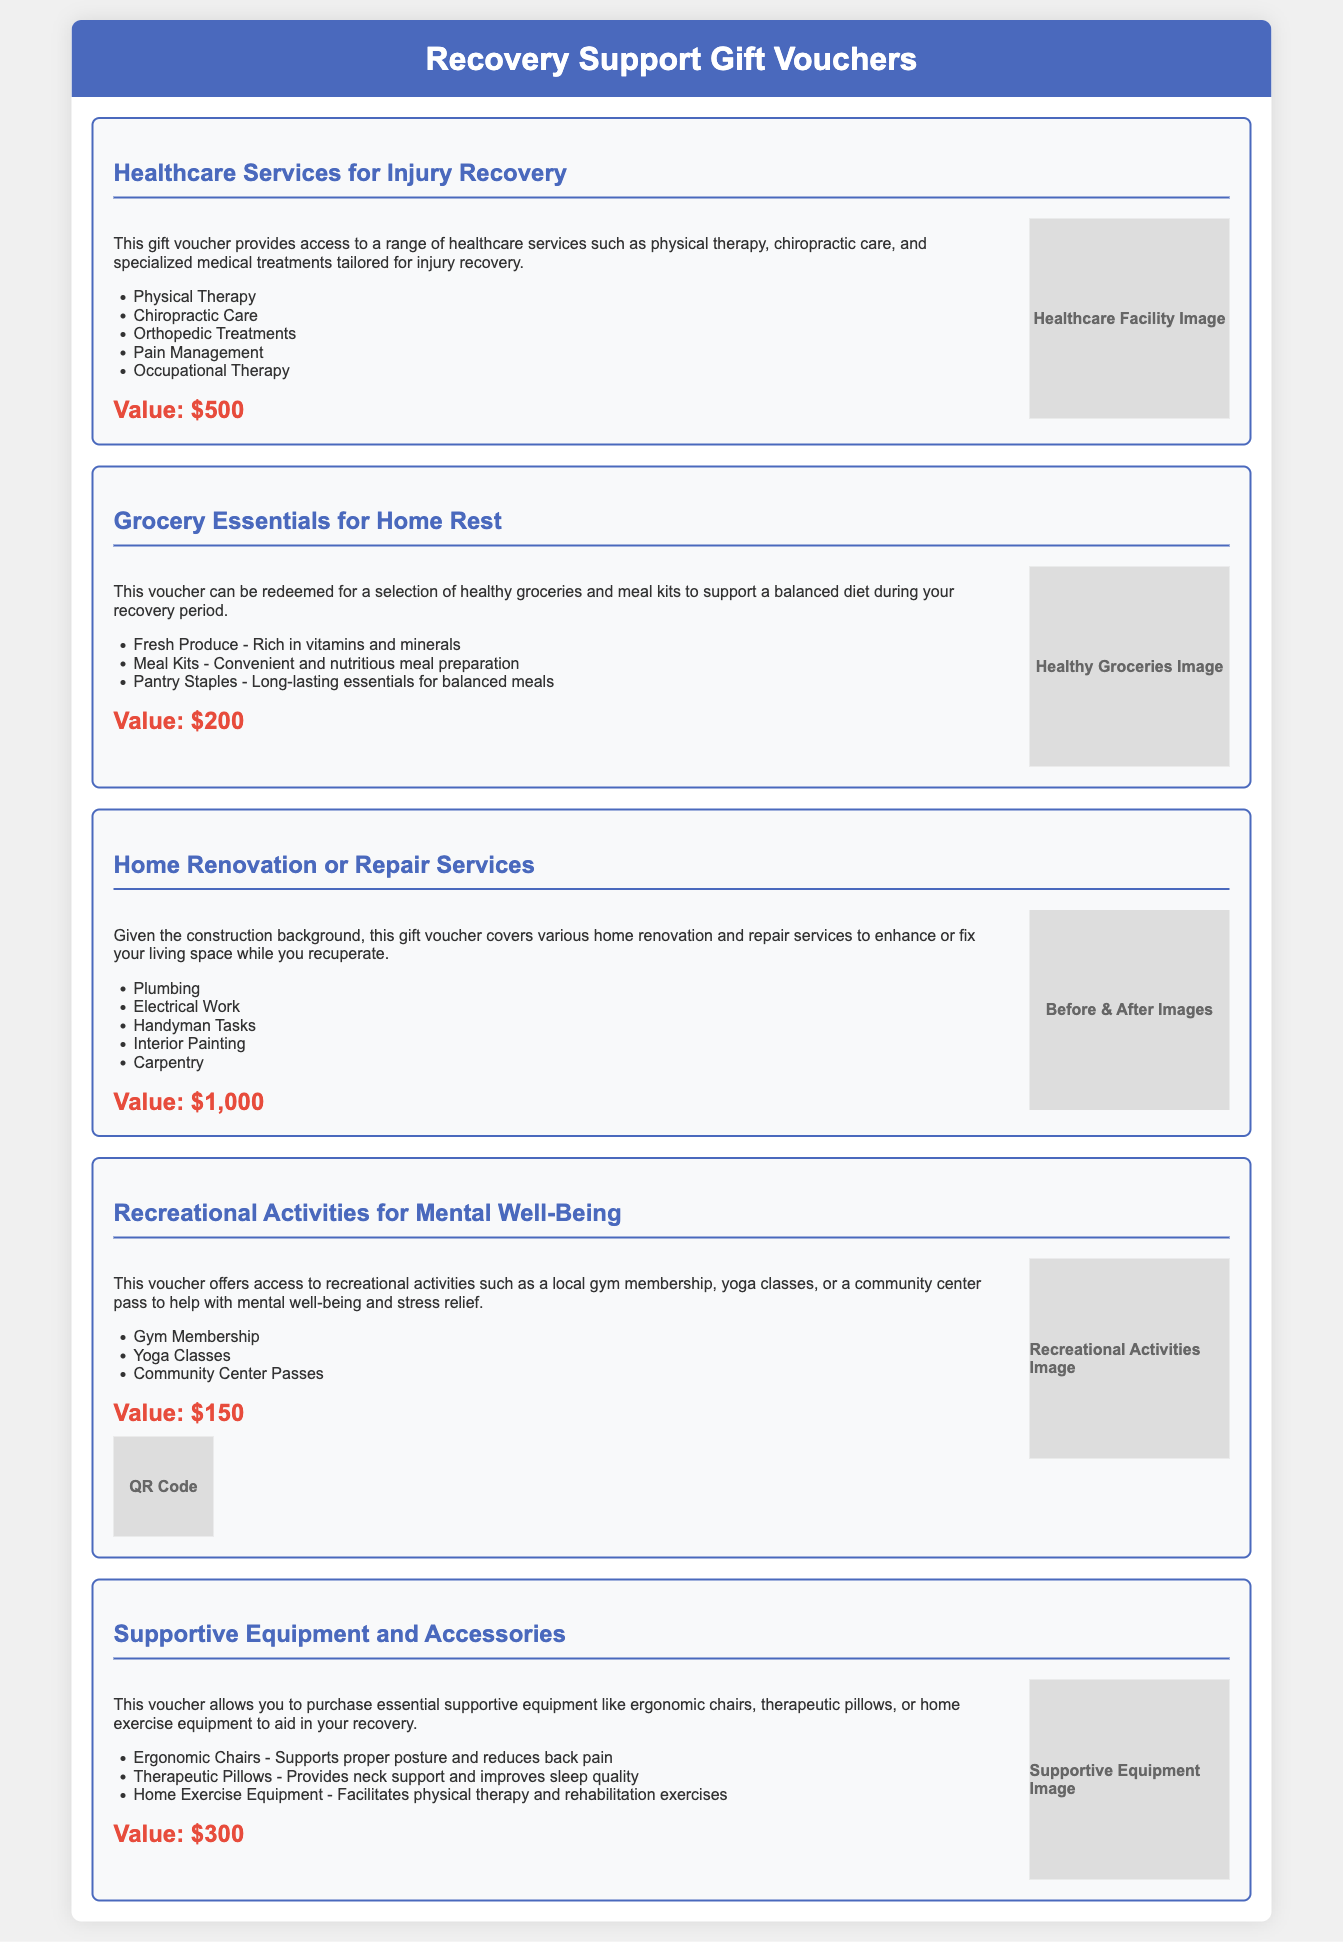What is the value of the Healthcare Services voucher? The value of the Healthcare Services voucher is prominently displayed in the document.
Answer: $500 What services are included in the Grocery Essentials voucher? A list of services included in the Grocery Essentials voucher is provided in the document.
Answer: Fresh Produce, Meal Kits, Pantry Staples How much is the Home Renovation or Repair Services voucher worth? The total amount for the Home Renovation or Repair Services voucher is indicated in the document.
Answer: $1,000 What type of activities does the Recreational Activities voucher offer? The document specifies the types of activities offered in the Recreational Activities voucher.
Answer: Gym Membership, Yoga Classes, Community Center Passes Which type of equipment can be purchased with the Supportive Equipment voucher? The Supportive Equipment voucher details the types of equipment available for purchase.
Answer: Ergonomic Chairs, Therapeutic Pillows, Home Exercise Equipment What is the purpose of the Healthcare Services voucher? The document explains the purpose of the Healthcare Services voucher in the context of injury recovery.
Answer: Access to healthcare services What is featured in the design of the Grocery Essentials voucher? The design elements of the Grocery Essentials voucher are described in the document.
Answer: Images of fresh produce, meal kits, and pantry staples How are the services in the Home Renovation voucher relevant to the construction background? The document discusses the relevance of the Home Renovation voucher to someone with a construction background.
Answer: Enhances or fixes living space 